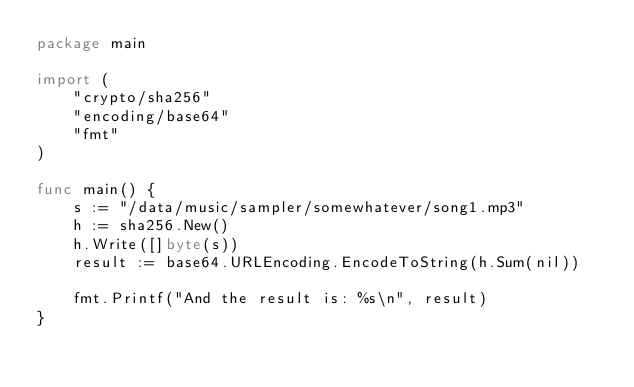<code> <loc_0><loc_0><loc_500><loc_500><_Go_>package main

import (
	"crypto/sha256"
	"encoding/base64"
	"fmt"
)

func main() {
	s := "/data/music/sampler/somewhatever/song1.mp3"
	h := sha256.New()
	h.Write([]byte(s))
	result := base64.URLEncoding.EncodeToString(h.Sum(nil))

	fmt.Printf("And the result is: %s\n", result)
}
</code> 